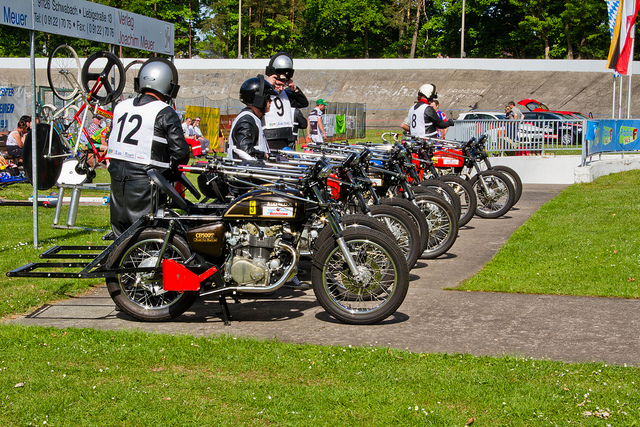Please identify all text content in this image. 12 9 Meuer 